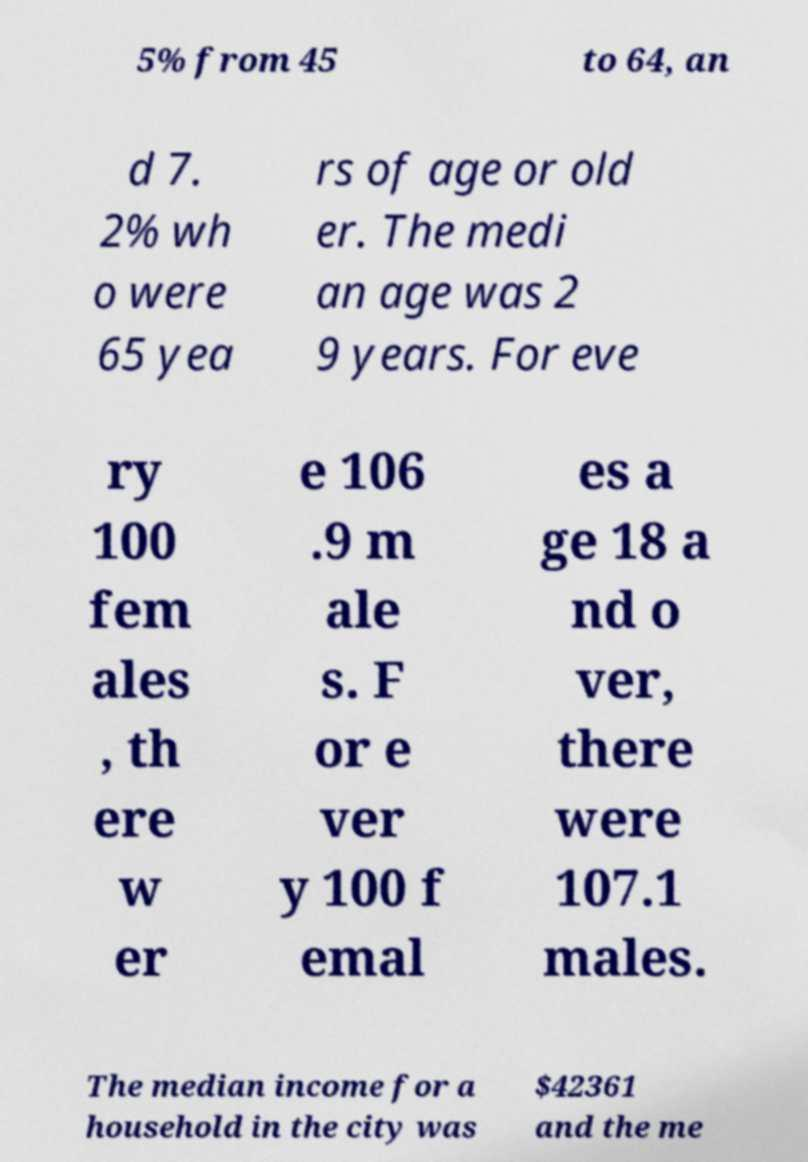I need the written content from this picture converted into text. Can you do that? 5% from 45 to 64, an d 7. 2% wh o were 65 yea rs of age or old er. The medi an age was 2 9 years. For eve ry 100 fem ales , th ere w er e 106 .9 m ale s. F or e ver y 100 f emal es a ge 18 a nd o ver, there were 107.1 males. The median income for a household in the city was $42361 and the me 